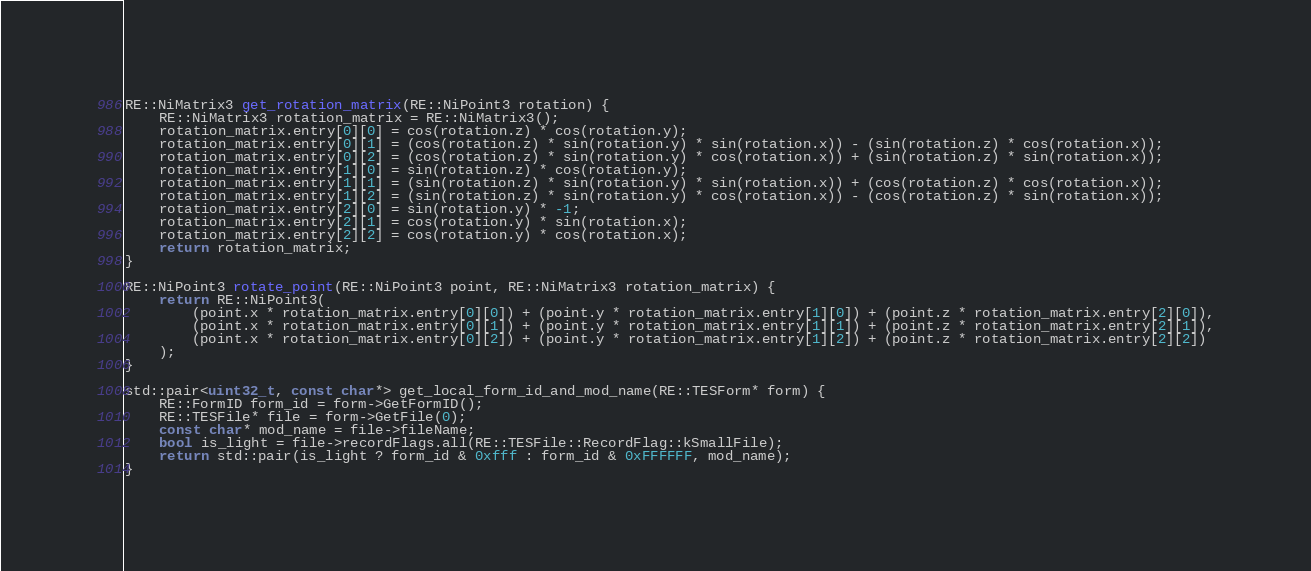<code> <loc_0><loc_0><loc_500><loc_500><_C++_>RE::NiMatrix3 get_rotation_matrix(RE::NiPoint3 rotation) {
	RE::NiMatrix3 rotation_matrix = RE::NiMatrix3();
	rotation_matrix.entry[0][0] = cos(rotation.z) * cos(rotation.y);
	rotation_matrix.entry[0][1] = (cos(rotation.z) * sin(rotation.y) * sin(rotation.x)) - (sin(rotation.z) * cos(rotation.x));
	rotation_matrix.entry[0][2] = (cos(rotation.z) * sin(rotation.y) * cos(rotation.x)) + (sin(rotation.z) * sin(rotation.x));
	rotation_matrix.entry[1][0] = sin(rotation.z) * cos(rotation.y);
	rotation_matrix.entry[1][1] = (sin(rotation.z) * sin(rotation.y) * sin(rotation.x)) + (cos(rotation.z) * cos(rotation.x));
	rotation_matrix.entry[1][2] = (sin(rotation.z) * sin(rotation.y) * cos(rotation.x)) - (cos(rotation.z) * sin(rotation.x));
	rotation_matrix.entry[2][0] = sin(rotation.y) * -1;
	rotation_matrix.entry[2][1] = cos(rotation.y) * sin(rotation.x);
	rotation_matrix.entry[2][2] = cos(rotation.y) * cos(rotation.x);
	return rotation_matrix;
}

RE::NiPoint3 rotate_point(RE::NiPoint3 point, RE::NiMatrix3 rotation_matrix) {
	return RE::NiPoint3(
		(point.x * rotation_matrix.entry[0][0]) + (point.y * rotation_matrix.entry[1][0]) + (point.z * rotation_matrix.entry[2][0]),
		(point.x * rotation_matrix.entry[0][1]) + (point.y * rotation_matrix.entry[1][1]) + (point.z * rotation_matrix.entry[2][1]),
		(point.x * rotation_matrix.entry[0][2]) + (point.y * rotation_matrix.entry[1][2]) + (point.z * rotation_matrix.entry[2][2])
	);
}

std::pair<uint32_t, const char*> get_local_form_id_and_mod_name(RE::TESForm* form) {
	RE::FormID form_id = form->GetFormID();
	RE::TESFile* file = form->GetFile(0);
	const char* mod_name = file->fileName;
	bool is_light = file->recordFlags.all(RE::TESFile::RecordFlag::kSmallFile);
	return std::pair(is_light ? form_id & 0xfff : form_id & 0xFFFFFF, mod_name);
}
</code> 